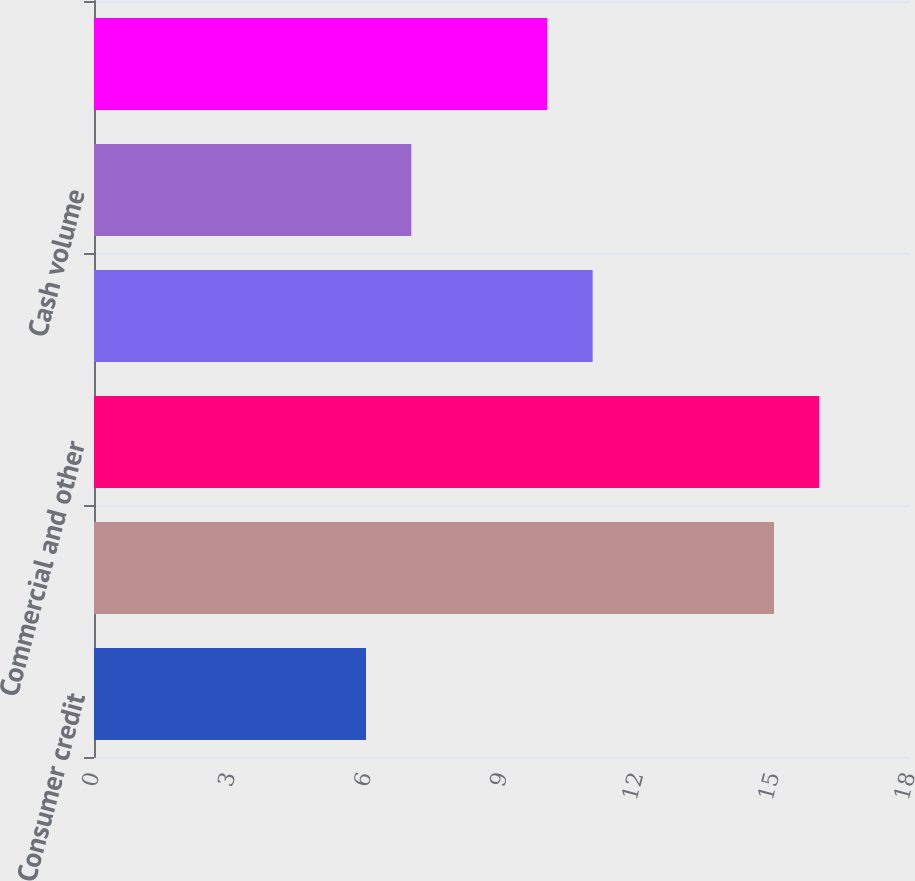Convert chart to OTSL. <chart><loc_0><loc_0><loc_500><loc_500><bar_chart><fcel>Consumer credit<fcel>Consumer debit (1)<fcel>Commercial and other<fcel>Total Payments Volume<fcel>Cash volume<fcel>Total Volume (2)<nl><fcel>6<fcel>15<fcel>16<fcel>11<fcel>7<fcel>10<nl></chart> 